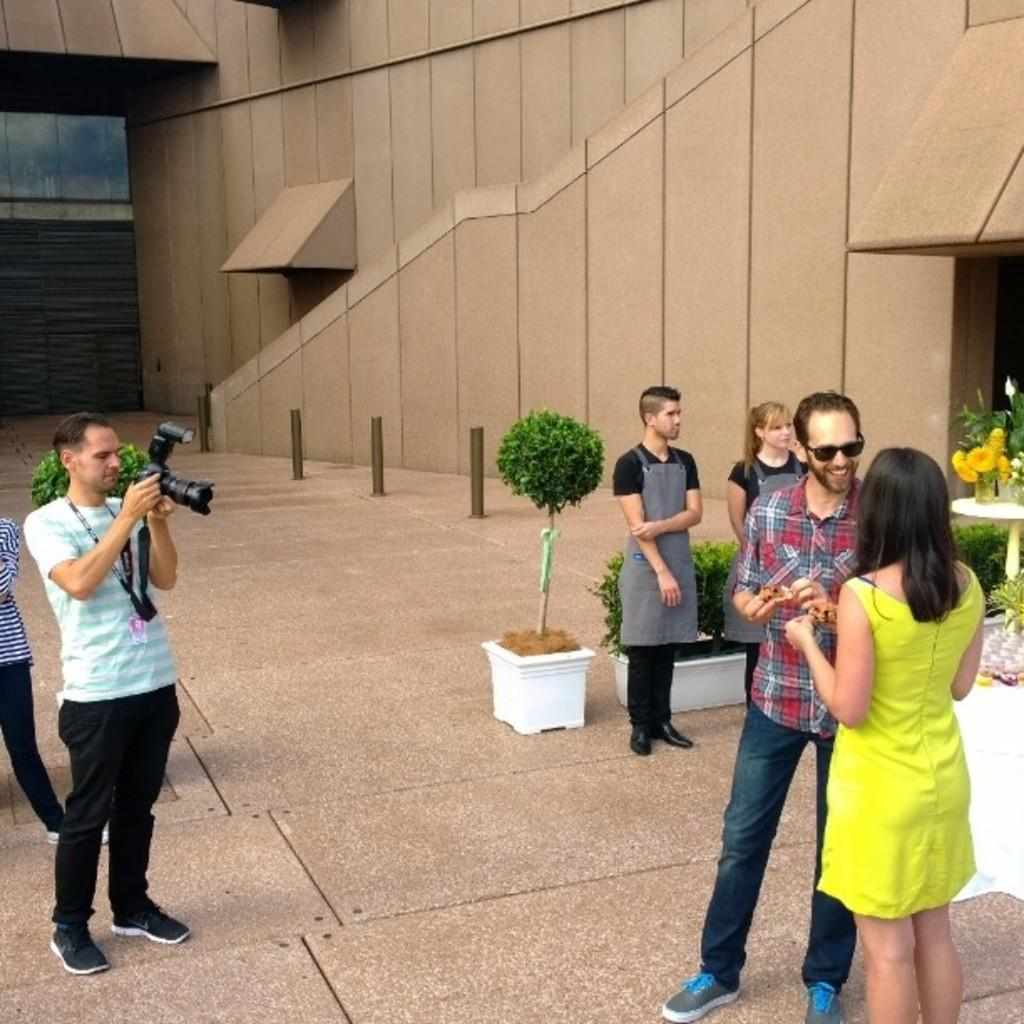What are the people in the image doing? The persons standing on the floor are likely engaged in some activity or standing in a particular location. What is the person holding in their hands? One of the persons is holding a camera in their hands. What type of plants can be seen in the image? There are houseplants visible in the image. What type of architectural features are present in the image? Walls are visible in the image. What objects are present to guide or control movement in the image? Barrier poles are present in the image. What type of books are being read by the jelly in the image? There is no jelly or books present in the image. Who is the uncle in the image? There is no mention of an uncle in the image. 